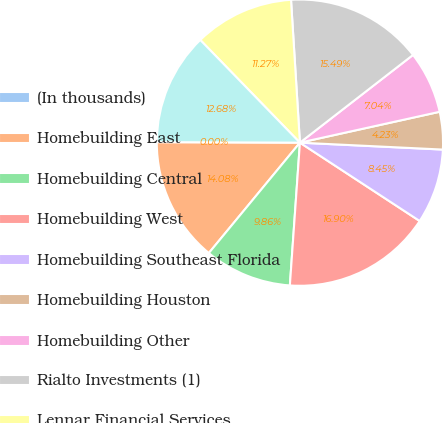<chart> <loc_0><loc_0><loc_500><loc_500><pie_chart><fcel>(In thousands)<fcel>Homebuilding East<fcel>Homebuilding Central<fcel>Homebuilding West<fcel>Homebuilding Southeast Florida<fcel>Homebuilding Houston<fcel>Homebuilding Other<fcel>Rialto Investments (1)<fcel>Lennar Financial Services<fcel>Corporate and unallocated<nl><fcel>0.0%<fcel>14.08%<fcel>9.86%<fcel>16.9%<fcel>8.45%<fcel>4.23%<fcel>7.04%<fcel>15.49%<fcel>11.27%<fcel>12.68%<nl></chart> 